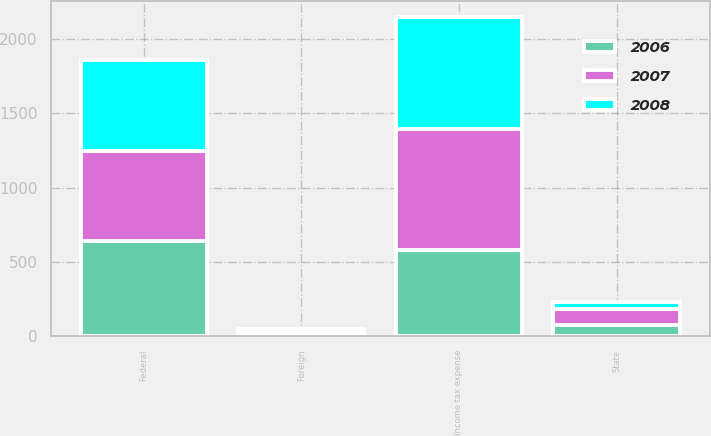Convert chart to OTSL. <chart><loc_0><loc_0><loc_500><loc_500><stacked_bar_chart><ecel><fcel>Federal<fcel>State<fcel>Foreign<fcel>Income tax expense<nl><fcel>2007<fcel>609<fcel>110<fcel>22<fcel>815<nl><fcel>2008<fcel>609<fcel>45<fcel>16<fcel>752<nl><fcel>2006<fcel>640<fcel>78<fcel>14<fcel>581<nl></chart> 